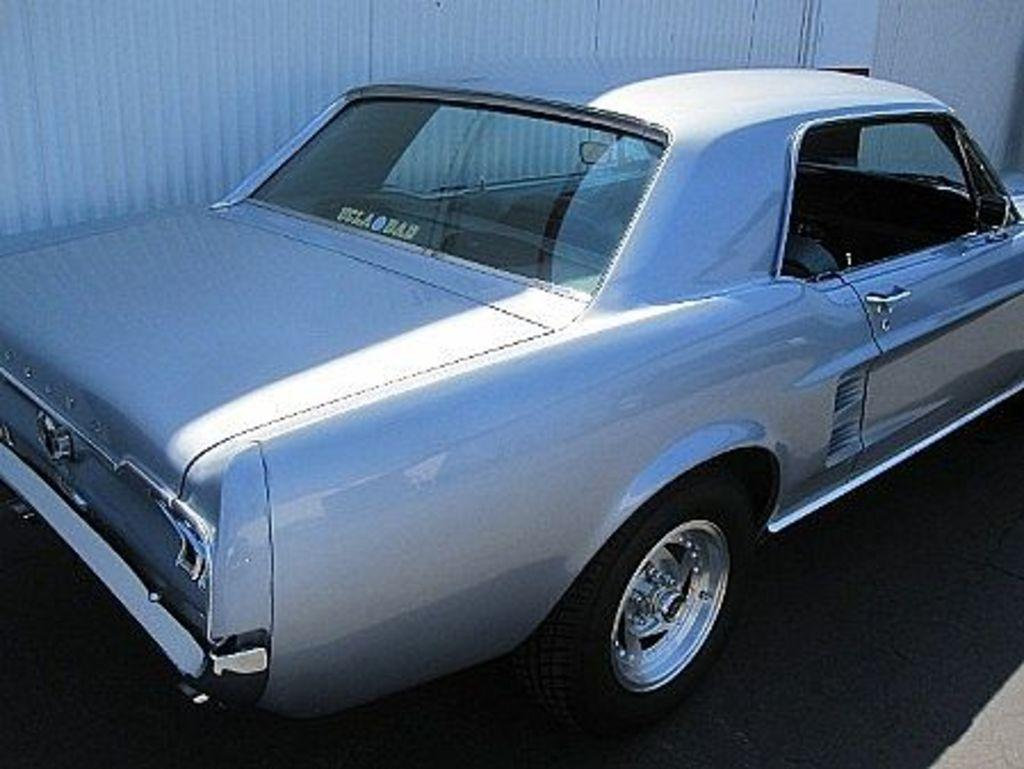What is the main subject of the image? There is a car in the image. Where is the car located in the image? The car is in the center of the image. What can be seen in the background of the image? There is a wall in the background of the image. What type of jewel is hanging from the swing in the image? There is no swing or jewel present in the image; it features a car in the center and a wall in the background. 